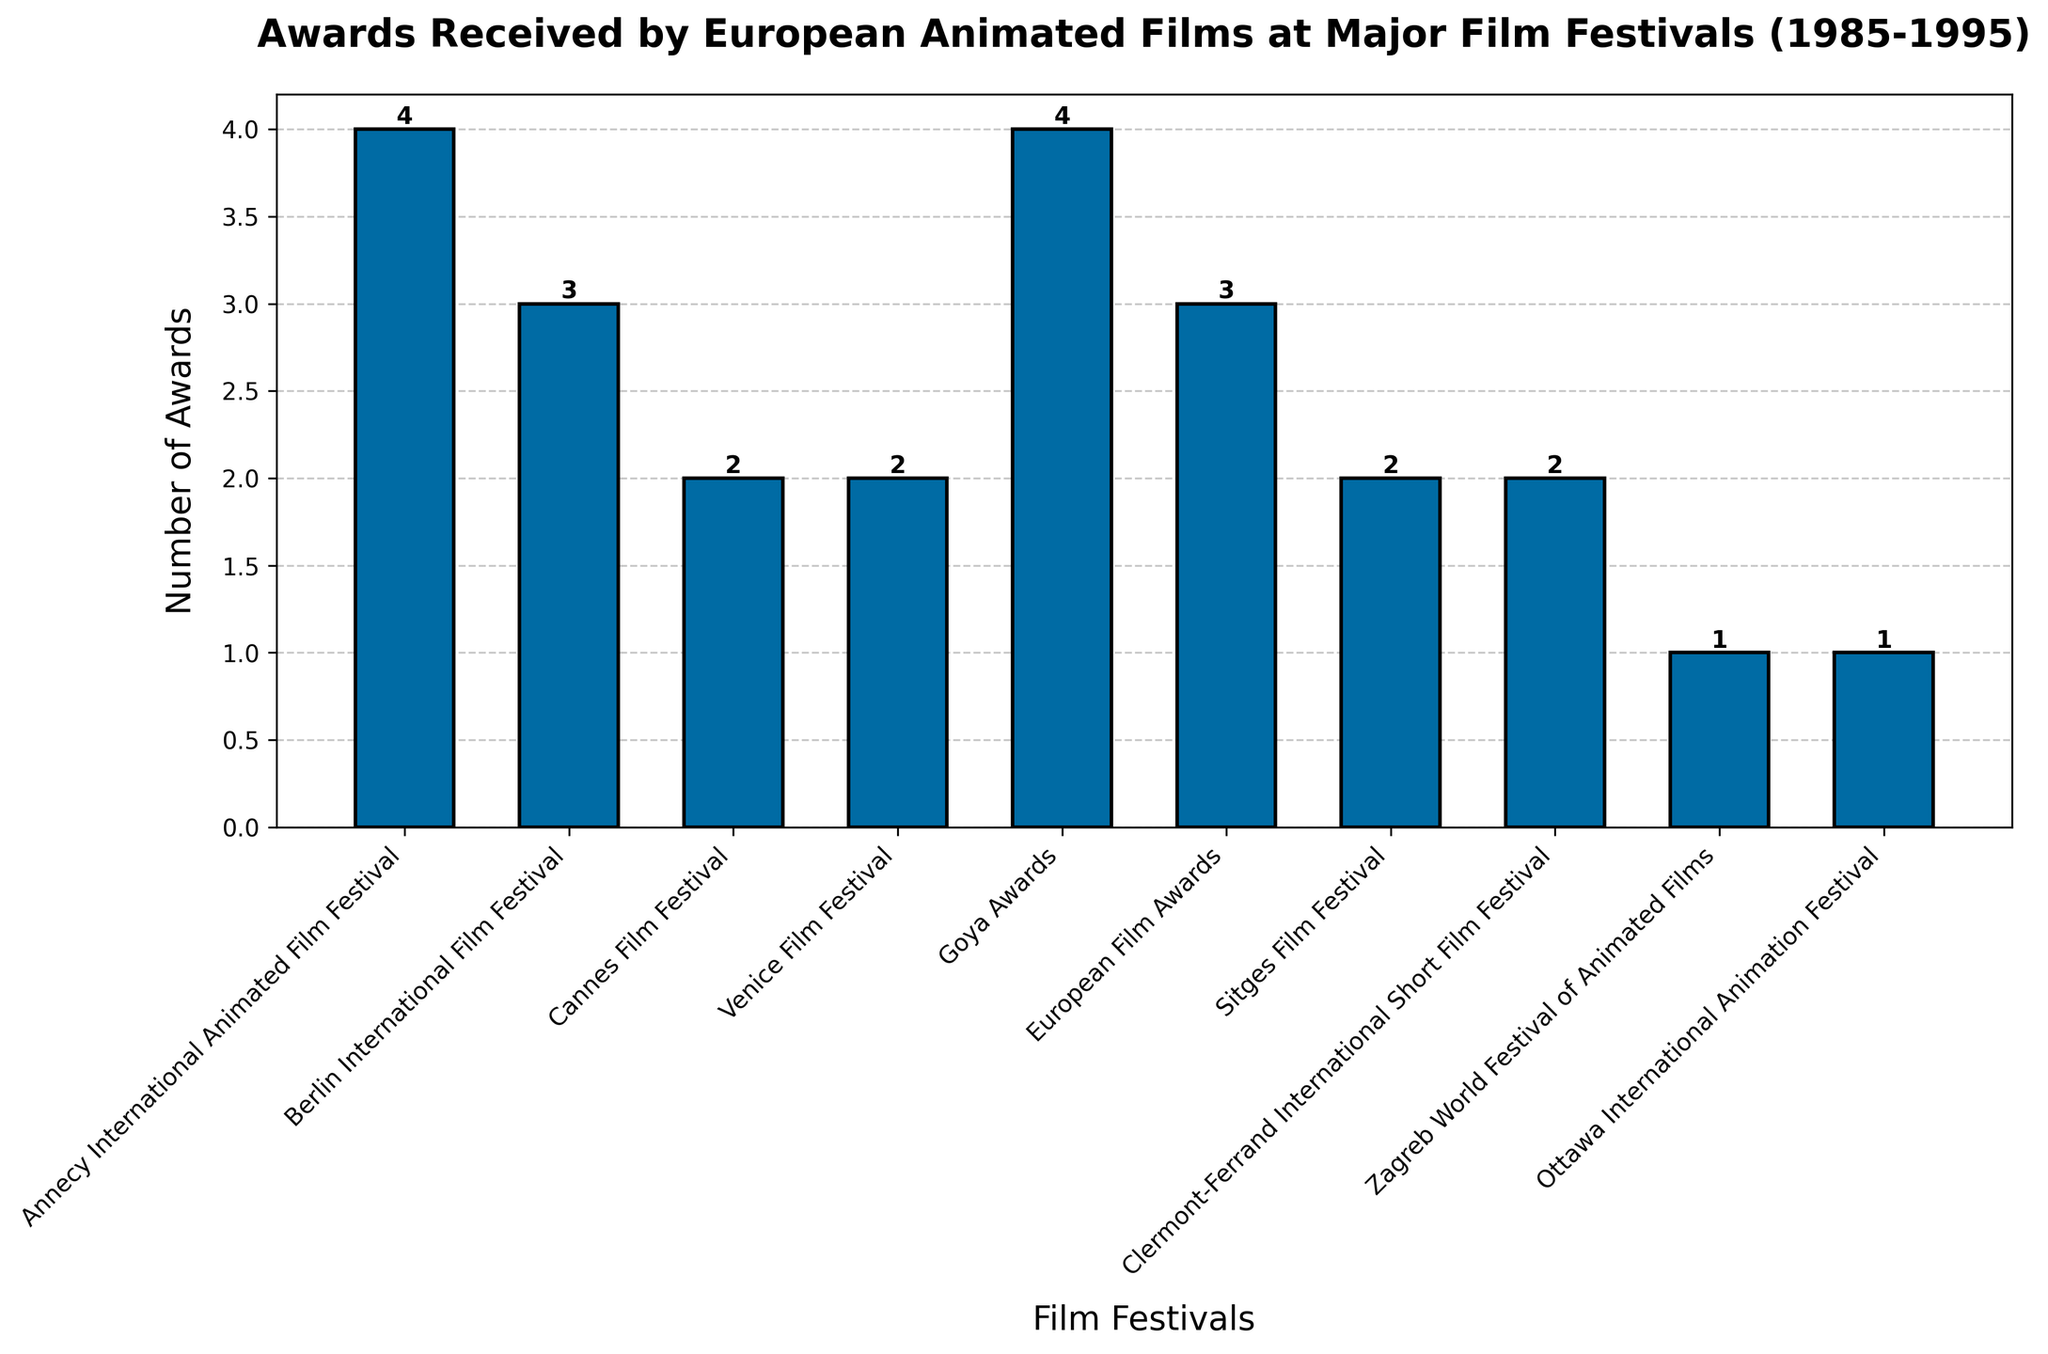Which film festival awarded the greatest number of awards to European animated films between 1985 and 1995? The bar representing the Annecy International Animated Film Festival is the tallest in the chart, indicating it has the highest number of awards.
Answer: Annecy International Animated Film Festival How many awards did films at the Berlin International Film Festival receive? Adding the heights of the two bars representing this festival, each with 1 and 2 awards respectively, gives a total of 1 + 2 = 3 awards.
Answer: 3 Comparing the Cannes Film Festival and the Clermont-Ferrand International Short Film Festival, which one awarded more films? Both film festivals are represented by bars of the same height, each showing 2 awards.
Answer: Both awarded equally What's the total number of awards given by the Goya Awards from 1985 to 1995? Summing the awards from both appearances of the Goya Awards: 2 from Megasónicos in 1989 and 1 from Peraustrinia 2004 in 1990, gives a total of 2 + 1 = 3 awards.
Answer: 3 What is the average number of awards given out per film festival? The total number of awards from all festivals is 18, and there are 10 unique festivals. The average is 18 / 10 = 1.8 awards per festival.
Answer: 1.8 Which film festival awarded films in only one year during this period but gave the second highest total number of awards? The Ottawa International Animation Festival awarded films only in 1988, and its total awards count is 2, which is the second highest for single-year awards.
Answer: Ottawa International Animation Festival Is there any instance where a film festival awarded more than 3 awards in a single year? No, the maximum height of any bar in the chart is 3, indicating no single festival awarded more than 3 awards in any given year.
Answer: No How many film festivals awarded exactly 1 award to films during this period? Counting the bars with a height of 1 shows five festivals awarded exactly 1 award: Berlin International, Venice, Sitges (1985), Zagreb, and Goya (1990).
Answer: 5 Which festival had the widest range of years in which it awarded films, and what is that range? Annecy International Animated Film Festival awarded films in 1987 and 1993. The range is 1993 - 1987 = 6 years, the widest in the chart.
Answer: Annecy International Animated Film Festival, 6 years Comparing Annecy International Animated Film Festival and European Film Awards, which one awarded fewer films and by how many? Annecy awarded a total of 4 awards (3 + 1), whereas the European Film Awards awarded 4 (1 + 3). Both have awarded the same total number of awards.
Answer: Neither, they both awarded 4 awards 